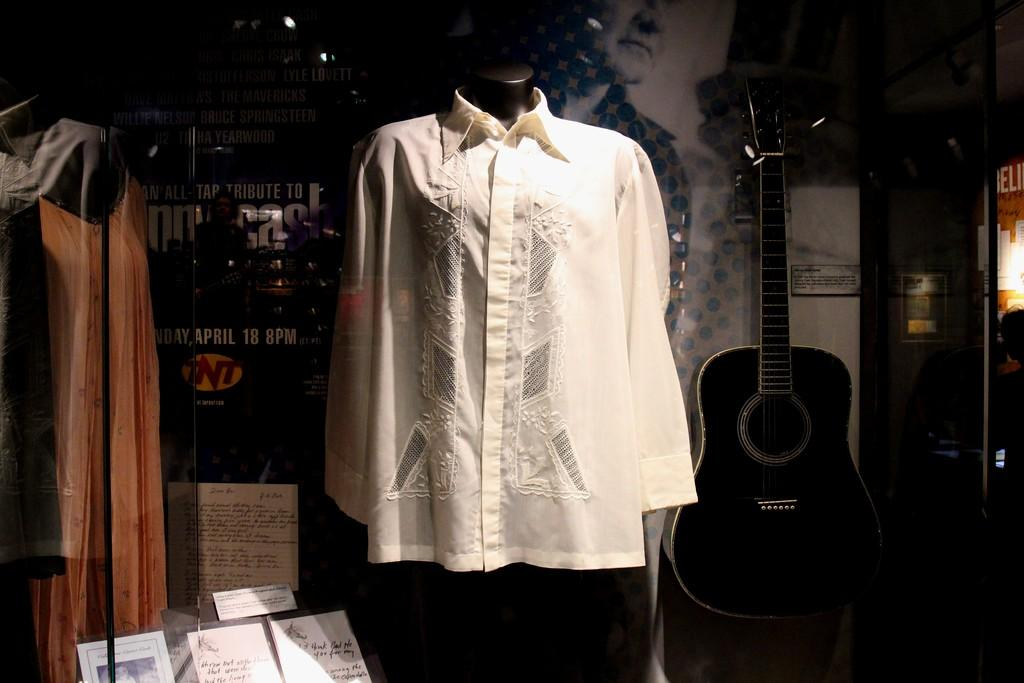What is the main object in the middle of the image? There is a shirt in the middle of the image. What musical instrument can be seen in the image? There is a guitar placed on a table at the right side of the image. What type of clothing is located at the left side of the image? There is a dress at the left side of the image. Can you tell me how many bricks are visible in the image? There are no bricks present in the image. Which direction is the river flowing in the image? There is no river present in the image. 